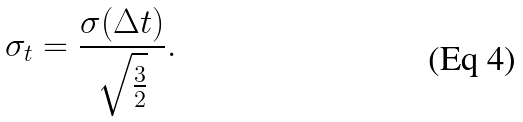Convert formula to latex. <formula><loc_0><loc_0><loc_500><loc_500>\sigma _ { t } = \frac { \sigma ( \Delta t ) } { \sqrt { \frac { 3 } { 2 } } } .</formula> 